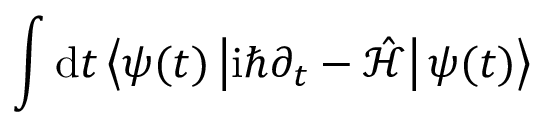<formula> <loc_0><loc_0><loc_500><loc_500>\int d t \left \langle \psi ( t ) \left | i \hbar { \partial } _ { t } - \mathcal { \hat { H } } \right | \psi ( t ) \right \rangle</formula> 